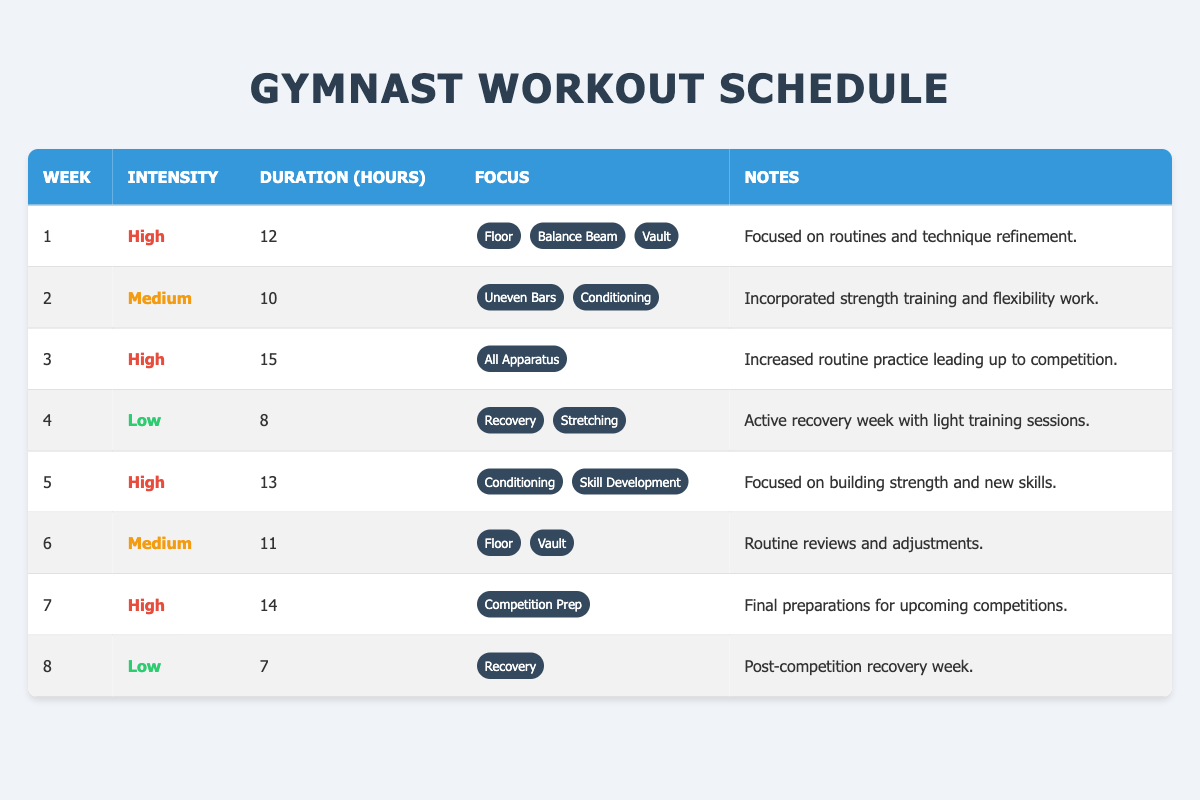What is the total workout duration for weeks with high intensity? High intensity workouts are scheduled in weeks 1, 3, 5, and 7. Their durations are 12, 15, 13, and 14 hours respectively. Summing these gives 12 + 15 + 13 + 14 = 54 hours.
Answer: 54 hours In which week was the lowest workout duration recorded? The lowest workout duration is found in week 8, where the duration is 7 hours. This can be confirmed by comparing the duration values across all weeks.
Answer: Week 8 How many hours were dedicated to medium intensity workouts in total? Medium intensity workouts occur in weeks 2 and 6, with durations of 10 and 11 hours respectively. Adding these gives 10 + 11 = 21 hours.
Answer: 21 hours Was there a week with a combined focus on recovery and stretching? Yes, in week 4, the focus included both recovery and stretching based on the provided data.
Answer: Yes What is the average duration of workouts across all eight weeks? The total durations for all weeks are 12, 10, 15, 8, 13, 11, 14, and 7 hours, which sum to 96 hours. To find the average, divide the total by the number of weeks: 96/8 = 12. Therefore, the average duration is 12 hours.
Answer: 12 hours 